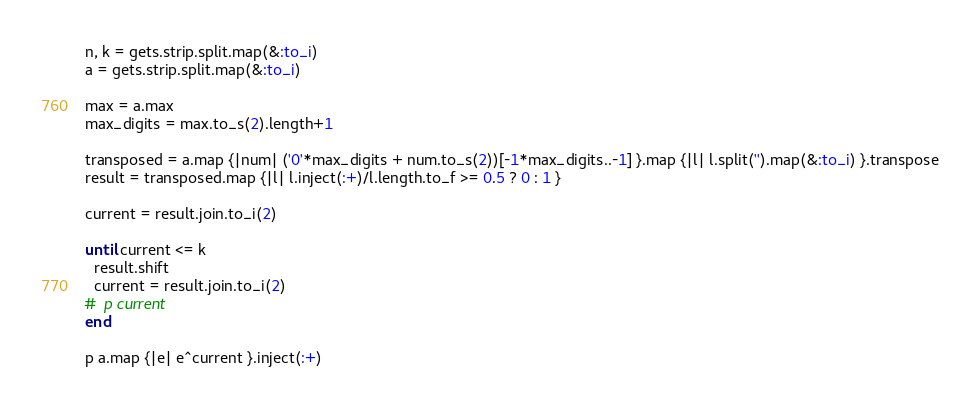<code> <loc_0><loc_0><loc_500><loc_500><_Ruby_>n, k = gets.strip.split.map(&:to_i)
a = gets.strip.split.map(&:to_i)

max = a.max
max_digits = max.to_s(2).length+1

transposed = a.map {|num| ('0'*max_digits + num.to_s(2))[-1*max_digits..-1] }.map {|l| l.split('').map(&:to_i) }.transpose
result = transposed.map {|l| l.inject(:+)/l.length.to_f >= 0.5 ? 0 : 1 }

current = result.join.to_i(2)

until current <= k
  result.shift
  current = result.join.to_i(2)
#  p current
end

p a.map {|e| e^current }.inject(:+)

</code> 